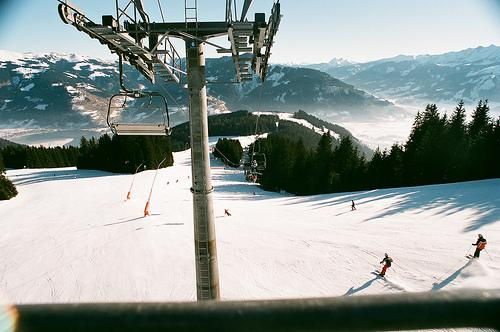Question: who are these people?
Choices:
A. The Monkees.
B. Superheroes.
C. Garbage men.
D. Skiers.
Answer with the letter. Answer: D Question: what are these people doing?
Choices:
A. Clapping.
B. Skating.
C. Surfing.
D. Skiing.
Answer with the letter. Answer: D Question: when was this photo taken?
Choices:
A. Summer.
B. Spring.
C. Fall.
D. Wintertime.
Answer with the letter. Answer: D Question: how long is the ski hill?
Choices:
A. 1 mile.
B. 2 miles.
C. A half mile.
D. .25 miles.
Answer with the letter. Answer: C Question: why are these people skiing?
Choices:
A. Parents forced them.
B. Nothing on TV.
C. It's their job.
D. It's fun.
Answer with the letter. Answer: D Question: what are the people holding?
Choices:
A. Newspapers.
B. Groceries.
C. Umbrellas.
D. Ski poles.
Answer with the letter. Answer: D 